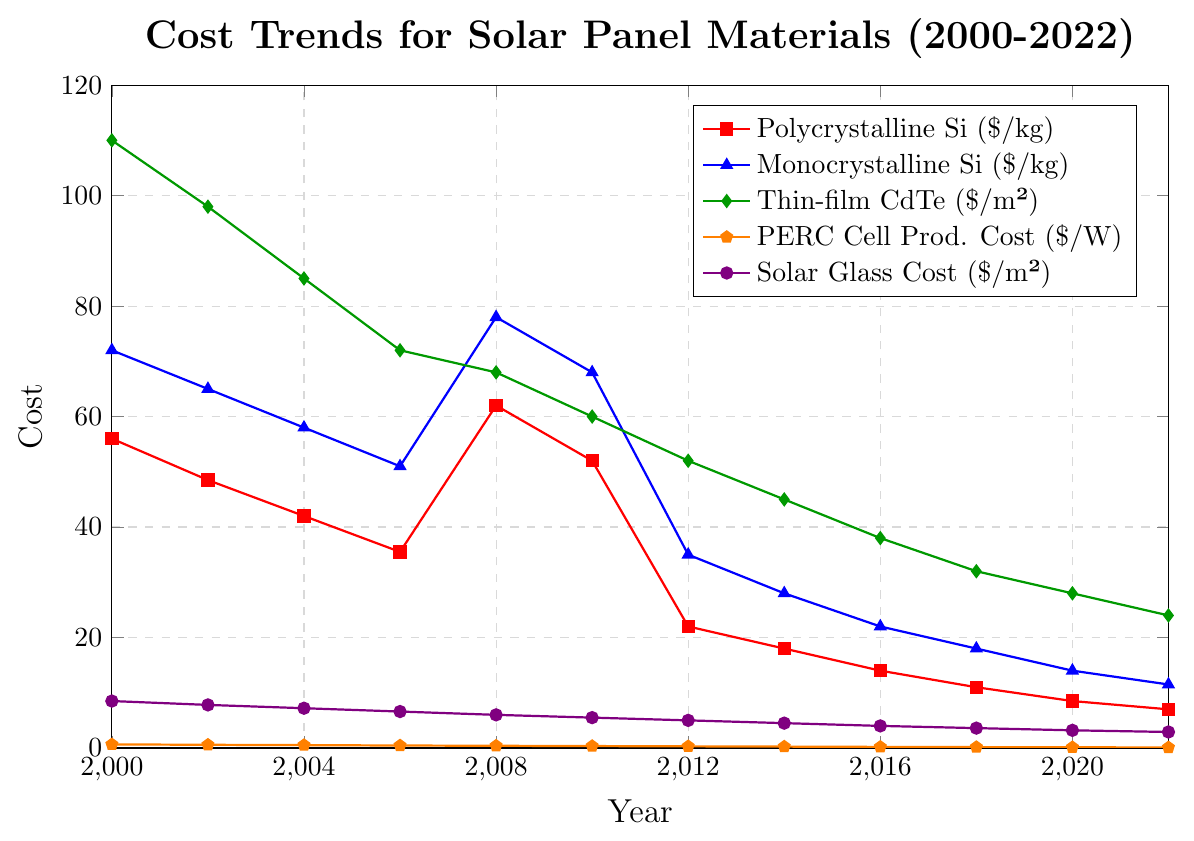Which material had the highest cost in 2006? Look at the data points for 2006. Compare the values for polycrystalline silicon, monocrystalline silicon, thin-film CdTe, PERC cell production cost, and solar glass cost. Thin-film CdTe has a cost of 72.00, which is the highest among all materials in 2006.
Answer: Thin-film CdTe How did the cost of polycrystalline silicon change between 2006 and 2008? Identify the cost of polycrystalline silicon in 2006 and 2008 from the data points. The cost was 35.50 in 2006 and increased to 62.00 in 2008. The change is calculated as 62.00 - 35.50.
Answer: Increased by 26.50 What is the percentage decrease in the PERC cell production cost from 2000 to 2022? Calculate the initial cost in 2000 and the final cost in 2022. The values are 0.65 and 0.10, respectively. The percentage decrease is calculated using the formula: ((0.65 - 0.10) / 0.65) * 100.
Answer: 84.62% Between which years did monocrystalline silicon see the biggest single-year drop in cost? Compare the cost values for monocrystalline silicon year by year to find the largest decrease. The biggest drop occurred between 2010 and 2012, with a difference of 68.00 - 35.00.
Answer: 2010-2012 What trend can you observe in the cost of solar glass over the years? Observe the data points for solar glass cost from 2000 to 2022. The cost shows a consistent decrease over the years. This indicates a downward trend.
Answer: Decreasing trend Which year shows a significant increase in the cost of polycrystalline silicon? Look for the year where there is a notable rise in the cost of polycrystalline silicon. In 2008, there is a significant increase from 35.50 in 2006 to 62.00.
Answer: 2008 Is the cost of thin-film CdTe in 2022 higher or lower than the cost of polycrystalline silicon and monocrystalline silicon in 2020? Compare the cost of thin-film CdTe in 2022 (24.00) with the cost of polycrystalline silicon (8.50) and monocrystalline silicon (14.00) in 2020. Thin-film CdTe (24.00) is higher than both.
Answer: Higher What is the average cost of solar glass from 2000 to 2022? Sum the cost values for solar glass over the years and divide by the number of data points: (8.50 + 7.80 + 7.20 + 6.60 + 6.00 + 5.50 + 5.00 + 4.50 + 4.00 + 3.60 + 3.20 + 2.90) / 12. This yields the average cost.
Answer: 5.15 How does the visual height of the costs in 2022 compare across the different materials? Observe the visual height of the end points for each material. Thin-film CdTe (24.00) is the highest, followed by polycrystalline silicon (7.00), monocrystalline silicon (11.50), solar glass (2.90), and PERC cell production cost (0.10).
Answer: Thin-film CdTe > Monocrystalline Si > Polycrystalline Si > Solar Glass > PERC 